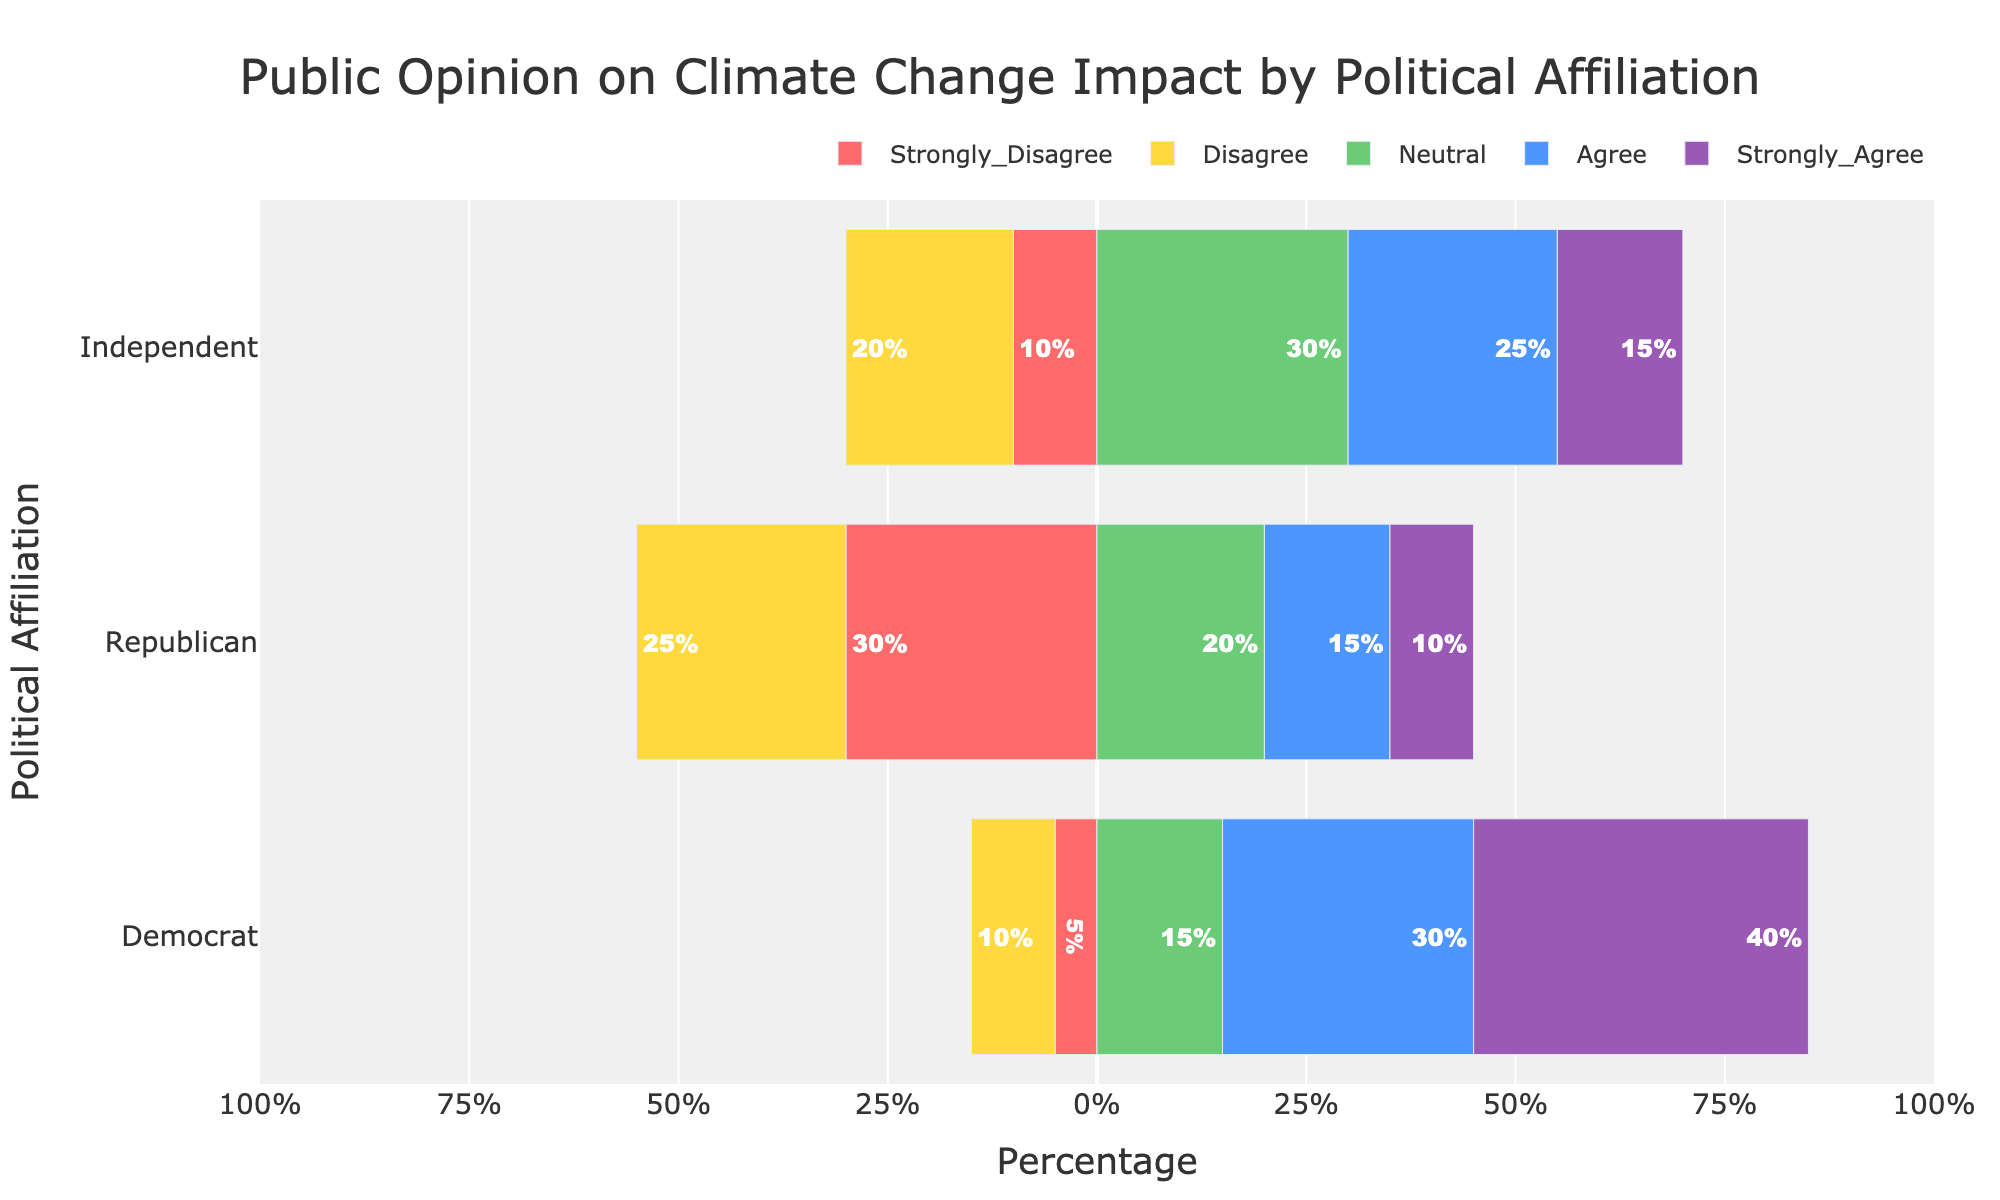Which political affiliation has the highest percentage of respondents who strongly agree with the impact of climate change? The figure shows the proportion of respondents who strongly agree with the impact of climate change by political affiliation. The bar representing "Strongly Agree" is the longest for the Democrat group.
Answer: Democrat Which political affiliation has the lowest percentage of respondents who agree with the impact of climate change? The figure shows the proportion of respondents who agree with the impact of climate change by political affiliation. The "Agree" category bar is shortest for the Republican group.
Answer: Republican What is the sum of percentages for Democrats who agree or strongly agree with the impact of climate change? Add the percentages of Democrats who agree (30%) and strongly agree (40%). 30% + 40% = 70%.
Answer: 70% Who has a higher percentage of respondents in the neutral category, Democrats or Independents? The figure shows both bars for the neutral category. The bar for Independents is longer than the bar for Democrats in the neutral category.
Answer: Independent What is the difference in the percentage of Republicans who strongly disagree versus disagree with the impact of climate change? Subtract the percentage of Republicans who disagree (25%) from those who strongly disagree (30%). 30% - 25% = 5%.
Answer: 5% Compare and identify which political affiliation has the most polarized opinion on climate change impact, considering strongly disagree and strongly agree categories. Check the ends of the spectrum ("Strongly Disagree" and "Strongly Agree"). Democrats have the highest percentage of "Strongly Agree" (40%) and Republicans have the highest percentage of "Strongly Disagree" (30%), but Democrats do not have significant "Strongly Disagree," whereas Republicans have significant disagreements throughout. Thus, Republicans are more polarized.
Answer: Republican Which political affiliation shows the most consensus around the neutral opinion? The "Neutral" category shows the percentage of respondents who neither agree nor disagree. Independents have the highest percentage in the neutral category (30%).
Answer: Independent What is the total percentage of responses for Republicans that fall under disagree and strongly disagree categories? Add the percentages for Republicans who disagree (25%) and strongly disagree (30%). 25% + 30% = 55%.
Answer: 55% Who has the smallest combined percentage of respondents who disagree or strongly disagree with the impact of climate change? Look at the "Disagree" and "Strongly Disagree" categories combined for each group. Democrats have the smallest combined percentage with 10% (disagree) + 5% (strongly disagree) = 15%.
Answer: Democrat 